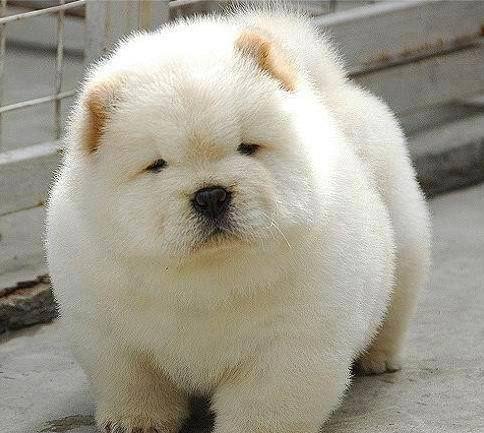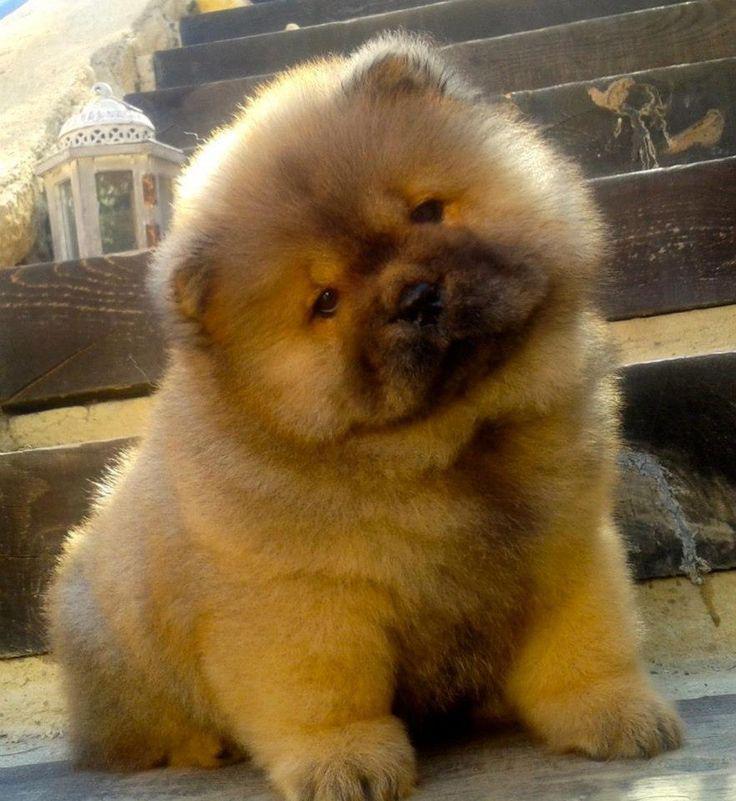The first image is the image on the left, the second image is the image on the right. Evaluate the accuracy of this statement regarding the images: "The right image shows a chow eyeing the camera, with its head turned at a distinct angle.". Is it true? Answer yes or no. Yes. The first image is the image on the left, the second image is the image on the right. For the images displayed, is the sentence "The white dog in the image on the left is standing on all fours." factually correct? Answer yes or no. Yes. 